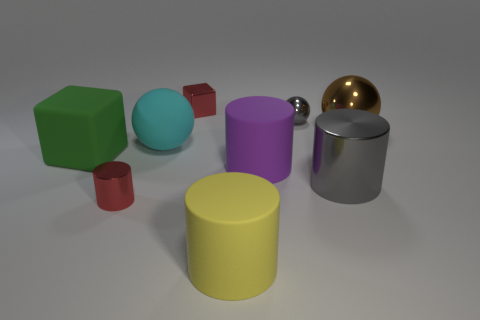What number of other things are the same color as the tiny ball?
Your answer should be very brief. 1. There is a purple thing; are there any large cyan things right of it?
Give a very brief answer. No. What number of things are either cyan things or large matte objects in front of the green cube?
Your answer should be very brief. 3. There is a small red shiny thing that is in front of the big block; are there any tiny red objects that are on the left side of it?
Make the answer very short. No. There is a small thing that is to the right of the cylinder that is in front of the red metal object that is to the left of the red metal cube; what is its shape?
Provide a short and direct response. Sphere. What is the color of the thing that is in front of the red cube and behind the large brown metal sphere?
Keep it short and to the point. Gray. The big shiny thing that is in front of the big brown shiny object has what shape?
Give a very brief answer. Cylinder. The tiny gray object that is made of the same material as the small red cube is what shape?
Keep it short and to the point. Sphere. What number of shiny objects are cylinders or purple spheres?
Your answer should be compact. 2. There is a matte cylinder behind the small object that is in front of the tiny metallic sphere; what number of big brown metal spheres are right of it?
Offer a very short reply. 1. 